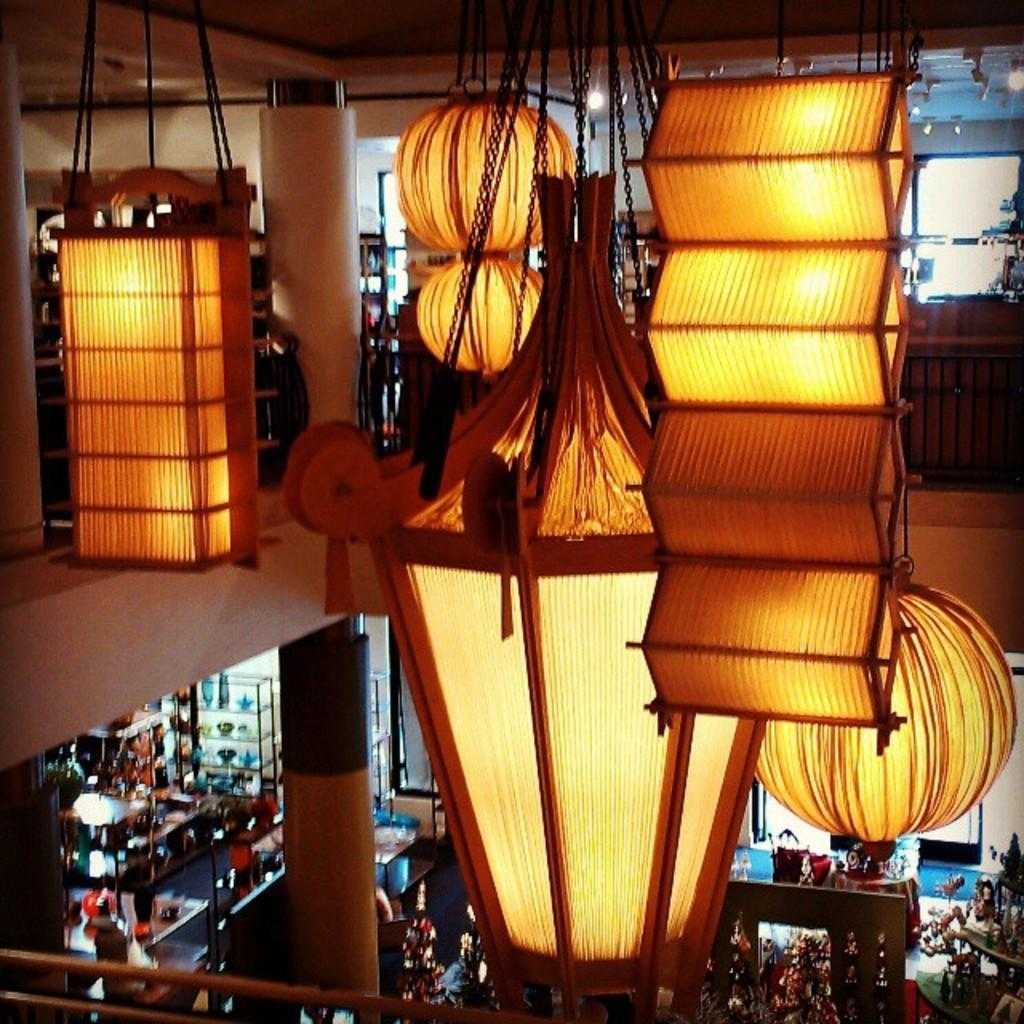What is the main structure visible in the image? There is a pillar in the image. What can be seen hanging in the image? There are objects hanging in the image. What objects are present at the bottom of the image? There are objects present at the bottom of the image. How many kittens are playing with a feather at the top of the pillar in the image? There are no kittens or feathers present in the image; it only features a pillar and objects hanging or at the bottom. 